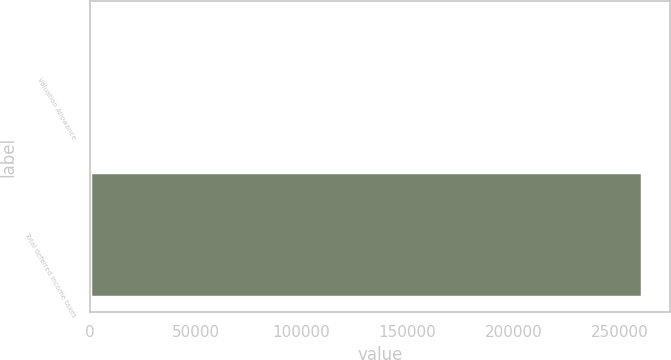<chart> <loc_0><loc_0><loc_500><loc_500><bar_chart><fcel>Valuation Allowance<fcel>Total deferred income taxes<nl><fcel>0.67<fcel>260870<nl></chart> 